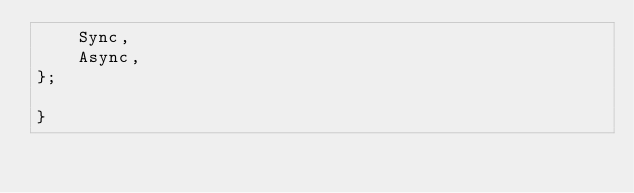Convert code to text. <code><loc_0><loc_0><loc_500><loc_500><_C++_>    Sync,
    Async,
};

}</code> 